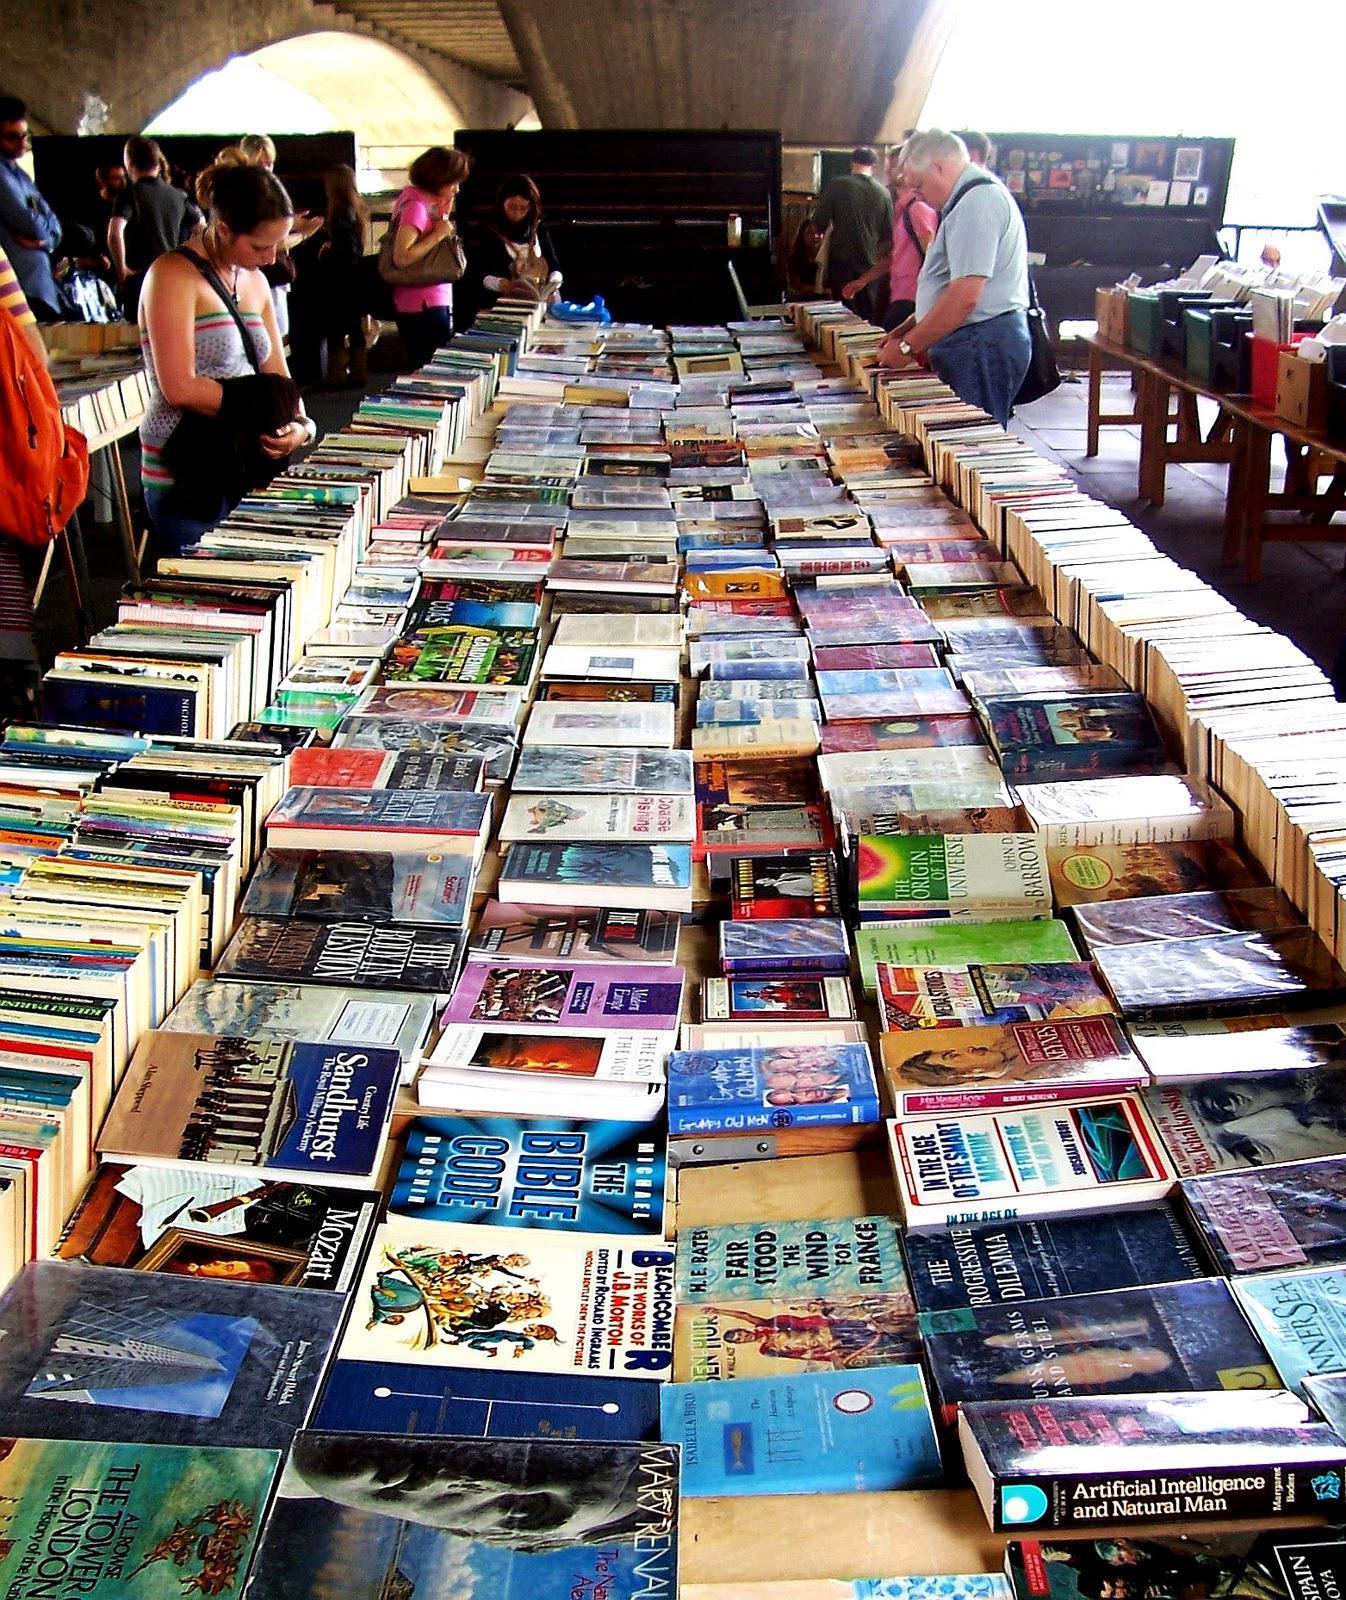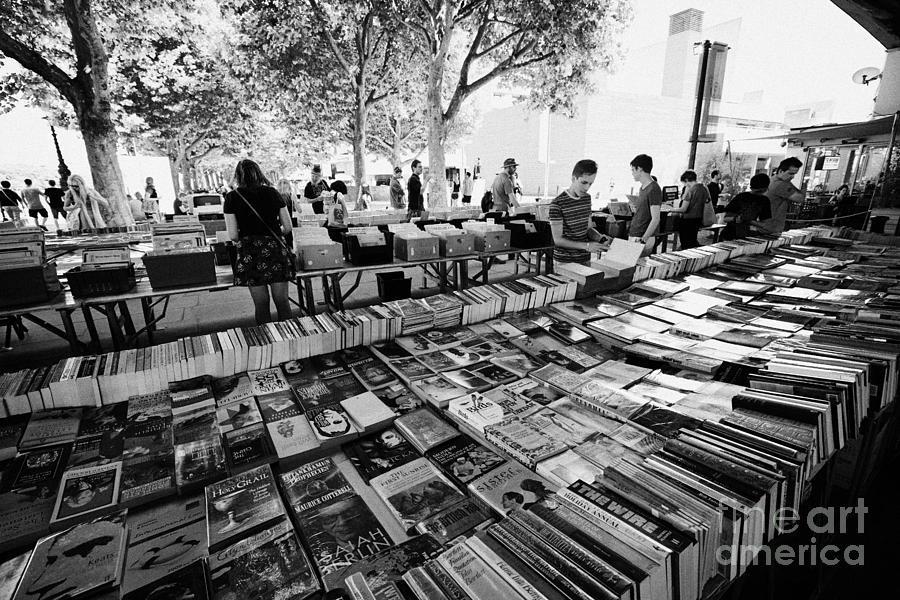The first image is the image on the left, the second image is the image on the right. For the images displayed, is the sentence "The left image is a head-on view of a long display of books under a narrow overhead structure, with the books stacked flat in several center rows, flanked on each side by a row of books stacked vertically, with people browsing on either side." factually correct? Answer yes or no. Yes. 